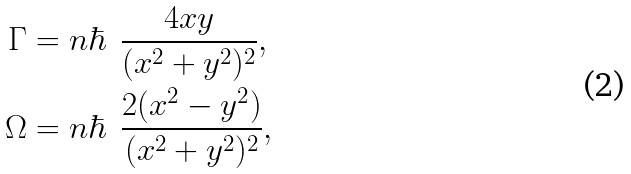<formula> <loc_0><loc_0><loc_500><loc_500>\Gamma & = n \hbar { \ } \, \frac { 4 x y } { ( x ^ { 2 } + y ^ { 2 } ) ^ { 2 } } , \\ \Omega & = n \hbar { \ } \, \frac { 2 ( x ^ { 2 } - y ^ { 2 } ) } { ( x ^ { 2 } + y ^ { 2 } ) ^ { 2 } } ,</formula> 